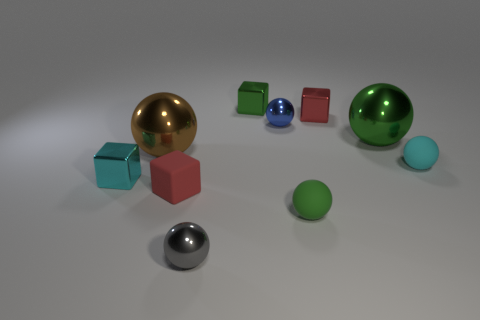Subtract 1 cubes. How many cubes are left? 3 Subtract all green spheres. How many spheres are left? 4 Subtract all big spheres. How many spheres are left? 4 Subtract all gray spheres. Subtract all cyan cylinders. How many spheres are left? 5 Subtract all cubes. How many objects are left? 6 Add 2 blue objects. How many blue objects exist? 3 Subtract 0 gray blocks. How many objects are left? 10 Subtract all small green rubber things. Subtract all small gray shiny things. How many objects are left? 8 Add 1 tiny cyan rubber objects. How many tiny cyan rubber objects are left? 2 